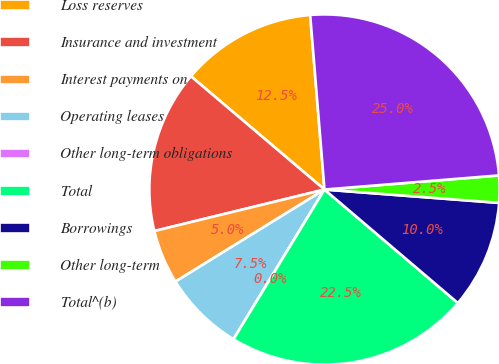<chart> <loc_0><loc_0><loc_500><loc_500><pie_chart><fcel>Loss reserves<fcel>Insurance and investment<fcel>Interest payments on<fcel>Operating leases<fcel>Other long-term obligations<fcel>Total<fcel>Borrowings<fcel>Other long-term<fcel>Total^(b)<nl><fcel>12.5%<fcel>15.0%<fcel>5.0%<fcel>7.5%<fcel>0.0%<fcel>22.47%<fcel>10.0%<fcel>2.5%<fcel>25.01%<nl></chart> 